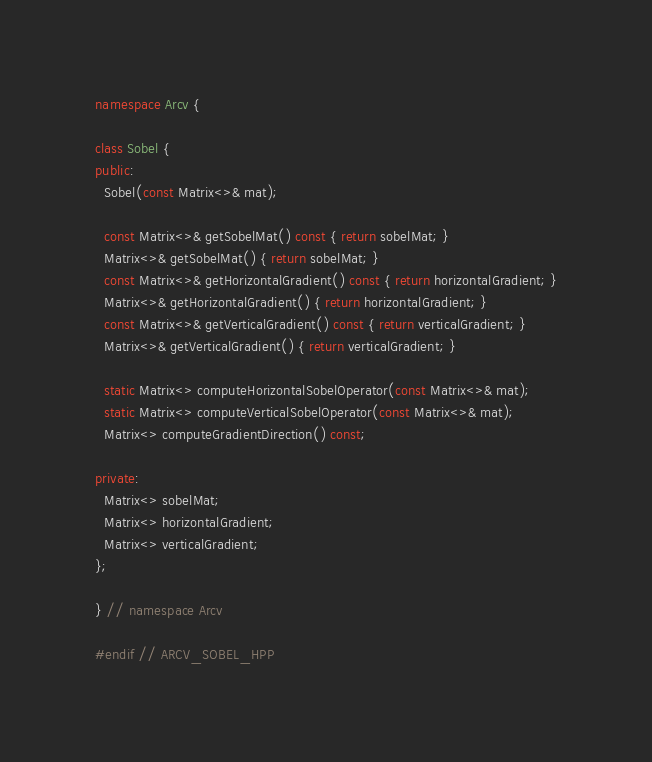Convert code to text. <code><loc_0><loc_0><loc_500><loc_500><_C++_>namespace Arcv {

class Sobel {
public:
  Sobel(const Matrix<>& mat);

  const Matrix<>& getSobelMat() const { return sobelMat; }
  Matrix<>& getSobelMat() { return sobelMat; }
  const Matrix<>& getHorizontalGradient() const { return horizontalGradient; }
  Matrix<>& getHorizontalGradient() { return horizontalGradient; }
  const Matrix<>& getVerticalGradient() const { return verticalGradient; }
  Matrix<>& getVerticalGradient() { return verticalGradient; }

  static Matrix<> computeHorizontalSobelOperator(const Matrix<>& mat);
  static Matrix<> computeVerticalSobelOperator(const Matrix<>& mat);
  Matrix<> computeGradientDirection() const;

private:
  Matrix<> sobelMat;
  Matrix<> horizontalGradient;
  Matrix<> verticalGradient;
};

} // namespace Arcv

#endif // ARCV_SOBEL_HPP
</code> 